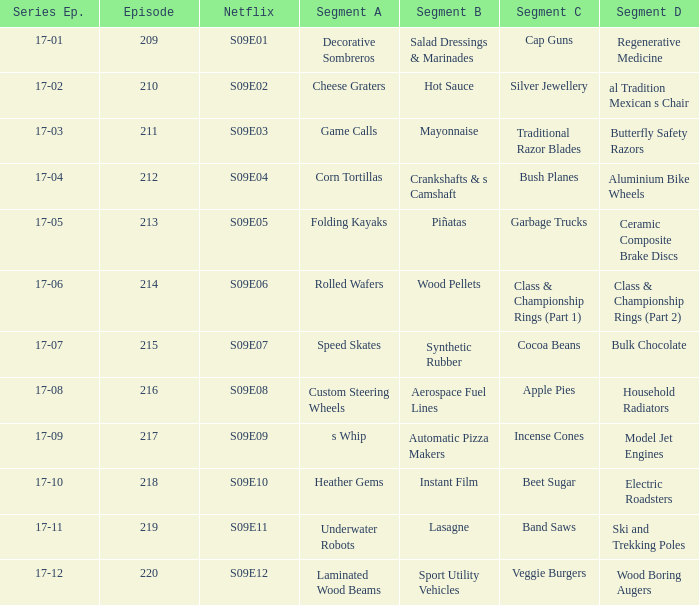For the shows featuring beet sugar, what was on before that Instant Film. 